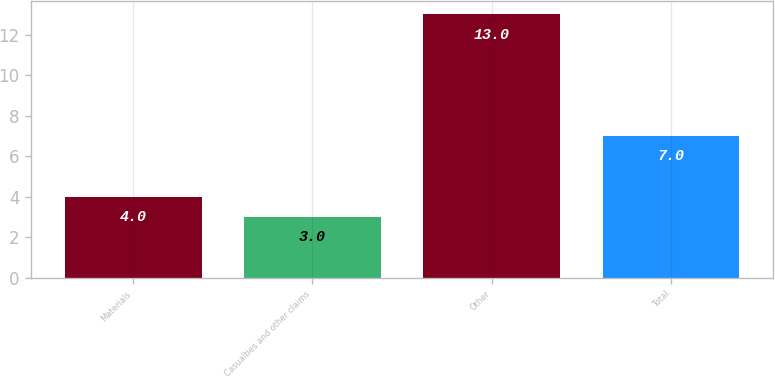<chart> <loc_0><loc_0><loc_500><loc_500><bar_chart><fcel>Materials<fcel>Casualties and other claims<fcel>Other<fcel>Total<nl><fcel>4<fcel>3<fcel>13<fcel>7<nl></chart> 